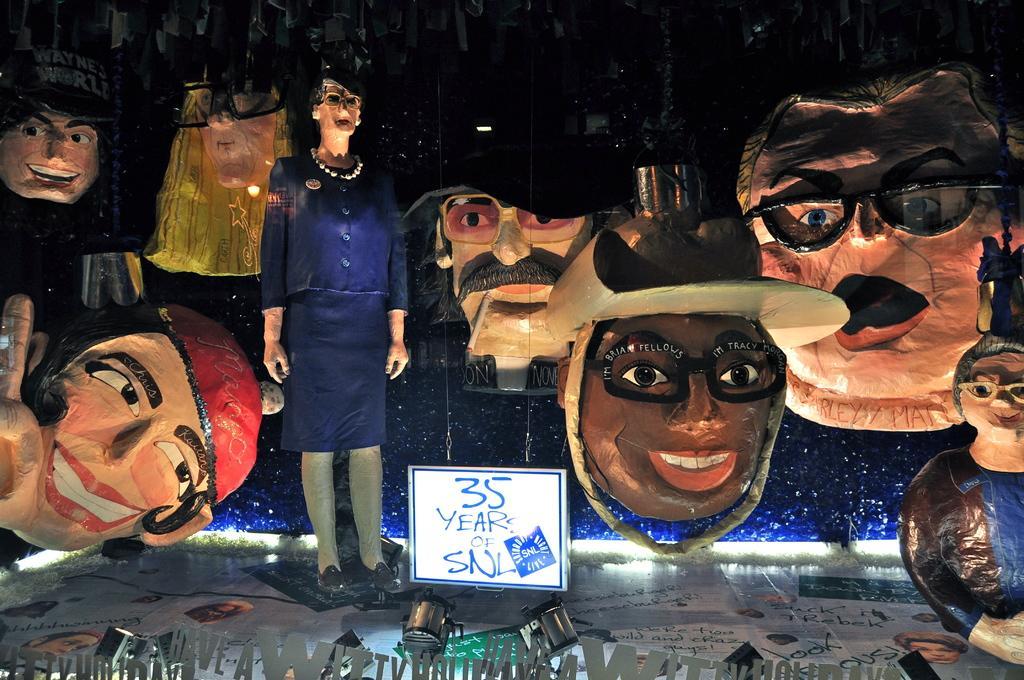Please provide a concise description of this image. In this image I can see depiction of faces and a sculpture in the centre. I can also see a white color board, few lights and I can see something is written on the board and on the bottom side of the image. 